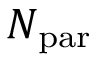<formula> <loc_0><loc_0><loc_500><loc_500>N _ { p a r }</formula> 